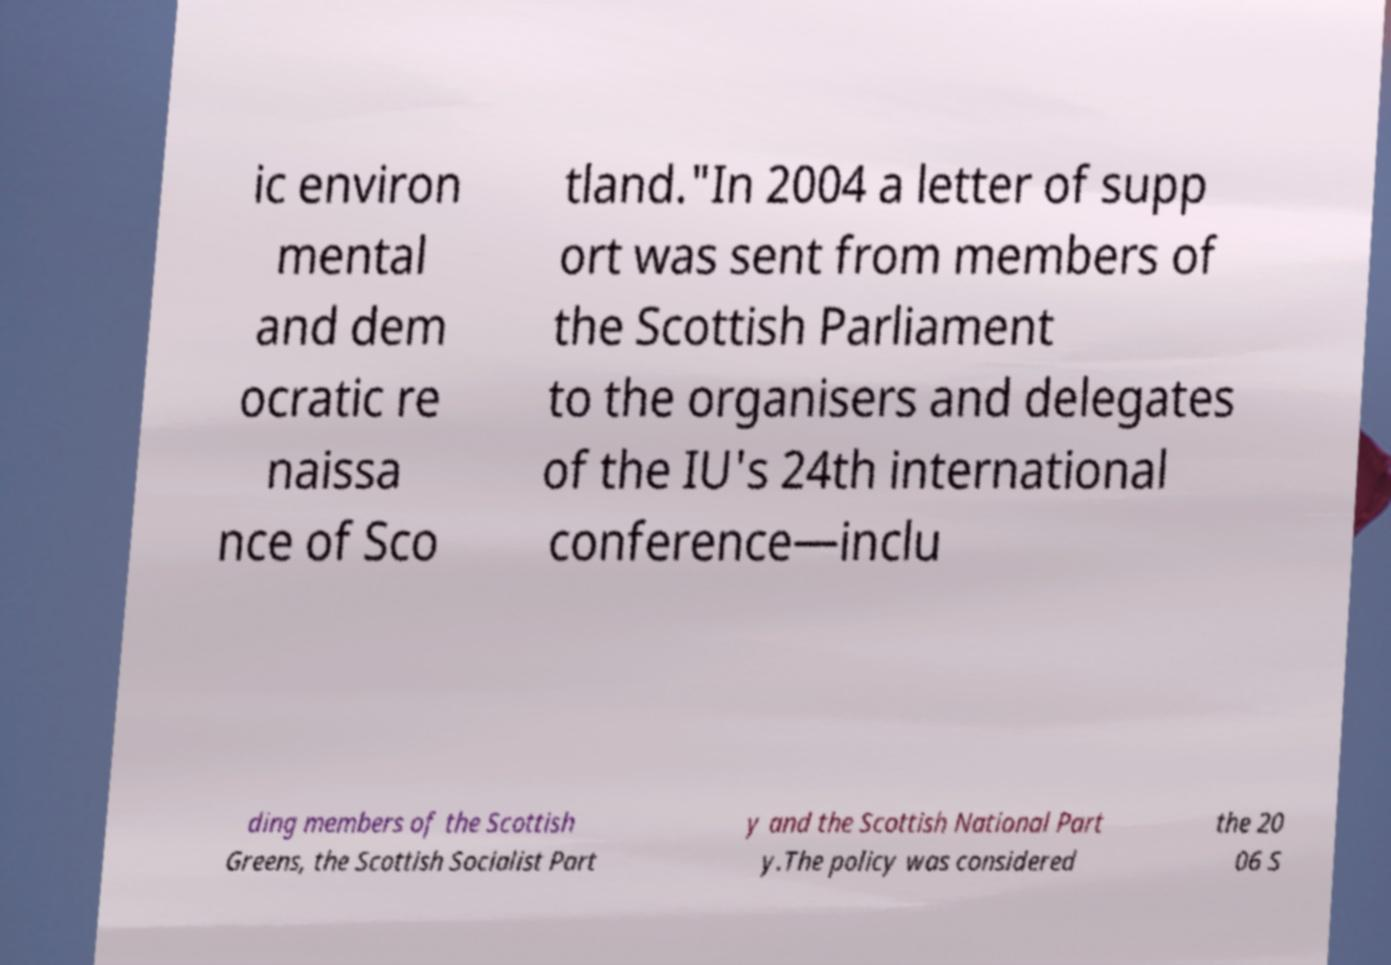Could you assist in decoding the text presented in this image and type it out clearly? ic environ mental and dem ocratic re naissa nce of Sco tland."In 2004 a letter of supp ort was sent from members of the Scottish Parliament to the organisers and delegates of the IU's 24th international conference—inclu ding members of the Scottish Greens, the Scottish Socialist Part y and the Scottish National Part y.The policy was considered the 20 06 S 